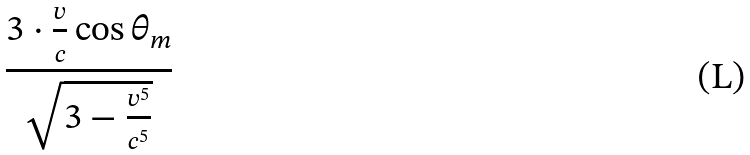<formula> <loc_0><loc_0><loc_500><loc_500>\frac { 3 \cdot \frac { v } { c } \cos \theta _ { m } } { \sqrt { 3 - \frac { v ^ { 5 } } { c ^ { 5 } } } }</formula> 